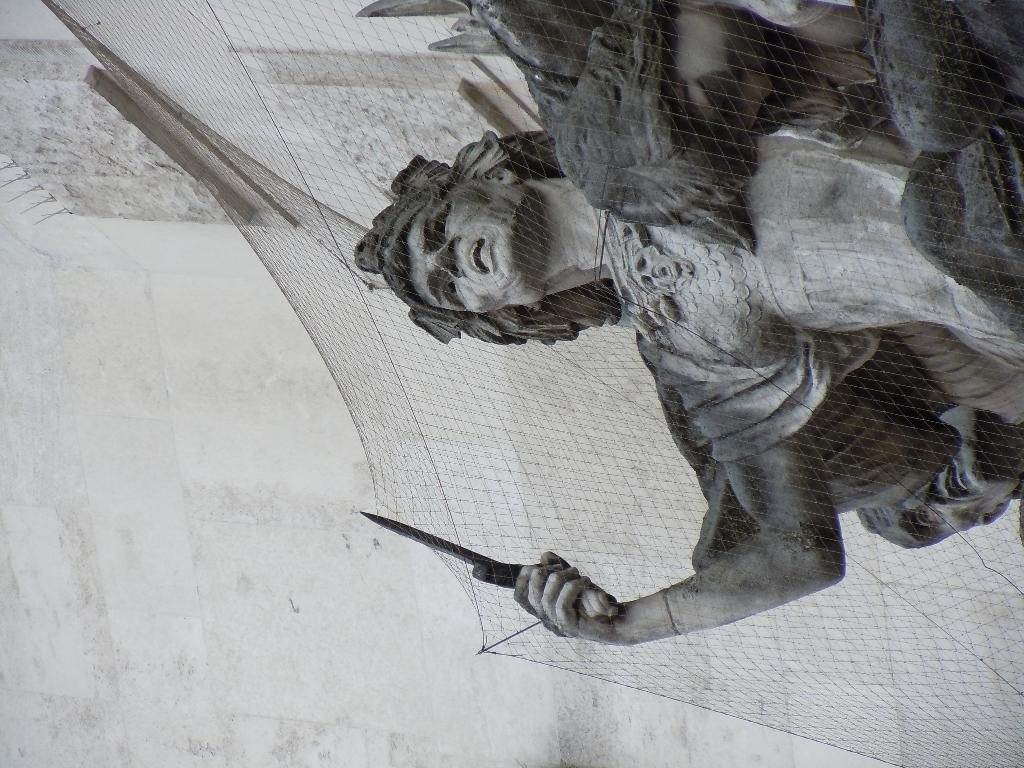What is the main subject of the image? There is a sculpture in the image. Where is the sculpture located in the image? The sculpture is on the right side of the image. What is covering the sculpture? There is a net covering the sculpture. What can be seen in the background of the image? There is a wall in the background of the image. What is the color scheme of the image? The image is black and white. What type of leather is draped over the tree in the image? There is no leather or tree present in the image; it features a sculpture with a net covering it and a wall in the background. How much powder is visible on the sculpture in the image? There is no powder visible on the sculpture in the image. 